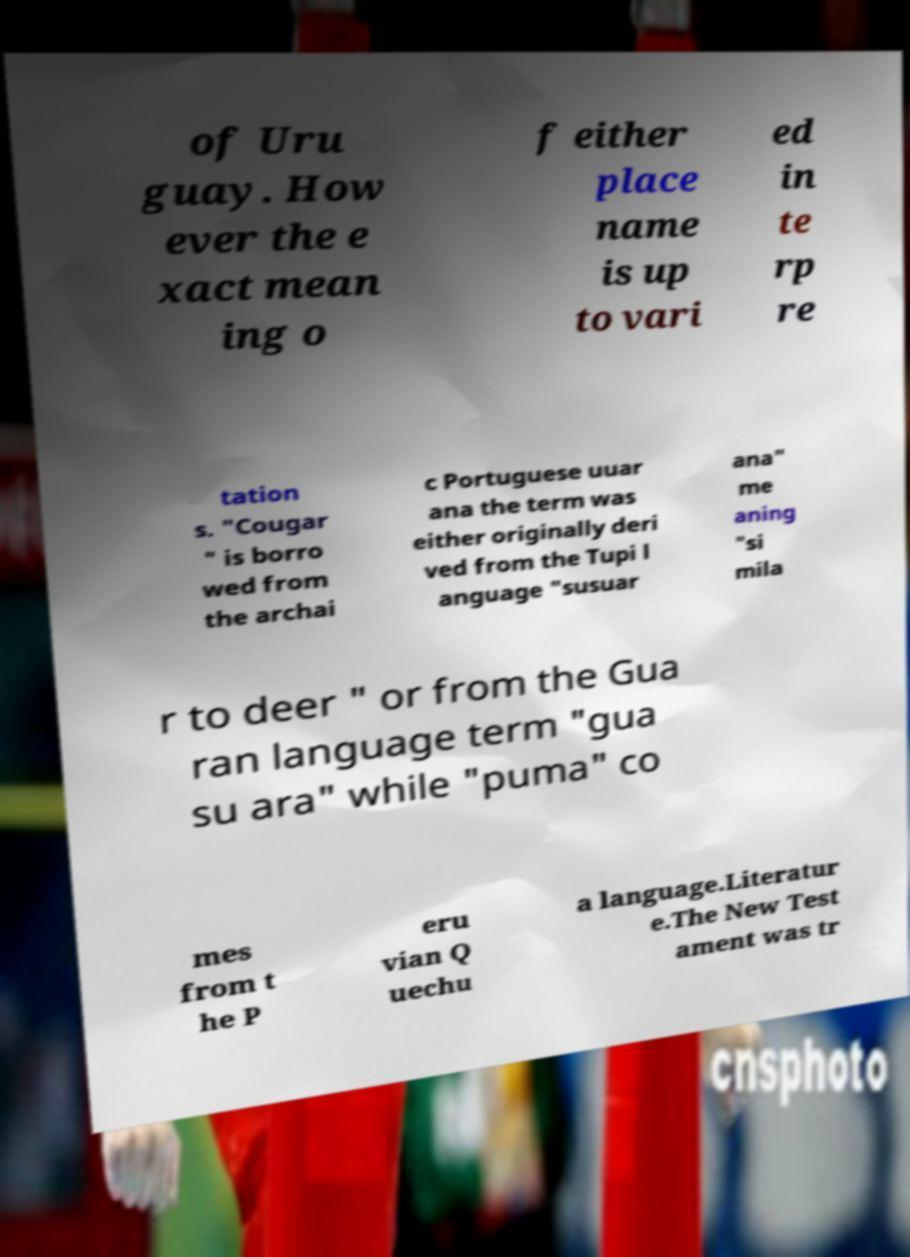There's text embedded in this image that I need extracted. Can you transcribe it verbatim? of Uru guay. How ever the e xact mean ing o f either place name is up to vari ed in te rp re tation s. "Cougar " is borro wed from the archai c Portuguese uuar ana the term was either originally deri ved from the Tupi l anguage "susuar ana" me aning "si mila r to deer " or from the Gua ran language term "gua su ara" while "puma" co mes from t he P eru vian Q uechu a language.Literatur e.The New Test ament was tr 